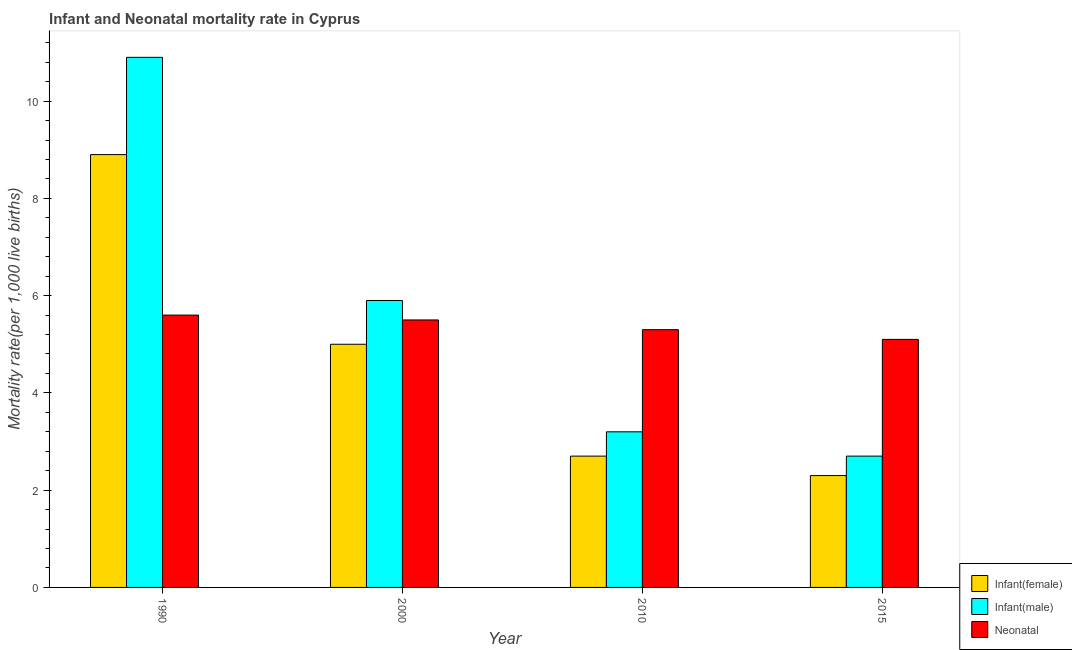How many different coloured bars are there?
Ensure brevity in your answer.  3. Are the number of bars per tick equal to the number of legend labels?
Offer a very short reply. Yes. How many bars are there on the 4th tick from the right?
Your answer should be very brief. 3. In how many cases, is the number of bars for a given year not equal to the number of legend labels?
Your answer should be compact. 0. What is the infant mortality rate(male) in 1990?
Ensure brevity in your answer.  10.9. Across all years, what is the maximum neonatal mortality rate?
Offer a very short reply. 5.6. In which year was the infant mortality rate(male) minimum?
Make the answer very short. 2015. What is the difference between the neonatal mortality rate in 2000 and that in 2010?
Give a very brief answer. 0.2. What is the average neonatal mortality rate per year?
Offer a very short reply. 5.38. In how many years, is the infant mortality rate(male) greater than 5.2?
Your answer should be very brief. 2. What is the ratio of the neonatal mortality rate in 2010 to that in 2015?
Give a very brief answer. 1.04. Is the difference between the infant mortality rate(male) in 1990 and 2010 greater than the difference between the neonatal mortality rate in 1990 and 2010?
Provide a short and direct response. No. What is the difference between the highest and the second highest neonatal mortality rate?
Give a very brief answer. 0.1. What is the difference between the highest and the lowest infant mortality rate(male)?
Provide a short and direct response. 8.2. Is the sum of the infant mortality rate(male) in 1990 and 2010 greater than the maximum infant mortality rate(female) across all years?
Make the answer very short. Yes. What does the 2nd bar from the left in 1990 represents?
Offer a terse response. Infant(male). What does the 3rd bar from the right in 2015 represents?
Keep it short and to the point. Infant(female). Is it the case that in every year, the sum of the infant mortality rate(female) and infant mortality rate(male) is greater than the neonatal mortality rate?
Your answer should be very brief. No. Are all the bars in the graph horizontal?
Your response must be concise. No. How many years are there in the graph?
Make the answer very short. 4. What is the difference between two consecutive major ticks on the Y-axis?
Give a very brief answer. 2. Are the values on the major ticks of Y-axis written in scientific E-notation?
Provide a succinct answer. No. What is the title of the graph?
Your answer should be compact. Infant and Neonatal mortality rate in Cyprus. What is the label or title of the Y-axis?
Ensure brevity in your answer.  Mortality rate(per 1,0 live births). What is the Mortality rate(per 1,000 live births) of Infant(female) in 1990?
Provide a short and direct response. 8.9. What is the Mortality rate(per 1,000 live births) in Infant(male) in 1990?
Offer a very short reply. 10.9. What is the Mortality rate(per 1,000 live births) in Neonatal  in 1990?
Provide a short and direct response. 5.6. What is the Mortality rate(per 1,000 live births) in Infant(female) in 2000?
Your response must be concise. 5. What is the Mortality rate(per 1,000 live births) of Neonatal  in 2000?
Your answer should be compact. 5.5. What is the Mortality rate(per 1,000 live births) of Neonatal  in 2010?
Provide a succinct answer. 5.3. What is the Mortality rate(per 1,000 live births) of Infant(female) in 2015?
Provide a succinct answer. 2.3. What is the Mortality rate(per 1,000 live births) of Neonatal  in 2015?
Give a very brief answer. 5.1. Across all years, what is the maximum Mortality rate(per 1,000 live births) in Infant(male)?
Offer a very short reply. 10.9. Across all years, what is the minimum Mortality rate(per 1,000 live births) in Neonatal ?
Provide a short and direct response. 5.1. What is the total Mortality rate(per 1,000 live births) in Infant(male) in the graph?
Your response must be concise. 22.7. What is the total Mortality rate(per 1,000 live births) of Neonatal  in the graph?
Your response must be concise. 21.5. What is the difference between the Mortality rate(per 1,000 live births) of Infant(male) in 1990 and that in 2000?
Keep it short and to the point. 5. What is the difference between the Mortality rate(per 1,000 live births) in Neonatal  in 1990 and that in 2000?
Your answer should be very brief. 0.1. What is the difference between the Mortality rate(per 1,000 live births) of Infant(female) in 2000 and that in 2010?
Offer a terse response. 2.3. What is the difference between the Mortality rate(per 1,000 live births) in Infant(male) in 2000 and that in 2010?
Offer a terse response. 2.7. What is the difference between the Mortality rate(per 1,000 live births) of Neonatal  in 2000 and that in 2010?
Offer a very short reply. 0.2. What is the difference between the Mortality rate(per 1,000 live births) of Infant(male) in 2000 and that in 2015?
Your response must be concise. 3.2. What is the difference between the Mortality rate(per 1,000 live births) in Neonatal  in 2010 and that in 2015?
Your answer should be compact. 0.2. What is the difference between the Mortality rate(per 1,000 live births) of Infant(female) in 1990 and the Mortality rate(per 1,000 live births) of Neonatal  in 2000?
Ensure brevity in your answer.  3.4. What is the difference between the Mortality rate(per 1,000 live births) in Infant(male) in 1990 and the Mortality rate(per 1,000 live births) in Neonatal  in 2000?
Your answer should be compact. 5.4. What is the difference between the Mortality rate(per 1,000 live births) of Infant(male) in 1990 and the Mortality rate(per 1,000 live births) of Neonatal  in 2010?
Offer a very short reply. 5.6. What is the difference between the Mortality rate(per 1,000 live births) in Infant(female) in 1990 and the Mortality rate(per 1,000 live births) in Neonatal  in 2015?
Your answer should be compact. 3.8. What is the difference between the Mortality rate(per 1,000 live births) in Infant(female) in 2000 and the Mortality rate(per 1,000 live births) in Infant(male) in 2010?
Your answer should be compact. 1.8. What is the difference between the Mortality rate(per 1,000 live births) of Infant(male) in 2010 and the Mortality rate(per 1,000 live births) of Neonatal  in 2015?
Give a very brief answer. -1.9. What is the average Mortality rate(per 1,000 live births) of Infant(female) per year?
Your answer should be compact. 4.72. What is the average Mortality rate(per 1,000 live births) of Infant(male) per year?
Provide a succinct answer. 5.67. What is the average Mortality rate(per 1,000 live births) in Neonatal  per year?
Your answer should be compact. 5.38. In the year 1990, what is the difference between the Mortality rate(per 1,000 live births) in Infant(female) and Mortality rate(per 1,000 live births) in Neonatal ?
Keep it short and to the point. 3.3. In the year 2000, what is the difference between the Mortality rate(per 1,000 live births) of Infant(female) and Mortality rate(per 1,000 live births) of Infant(male)?
Your answer should be compact. -0.9. In the year 2000, what is the difference between the Mortality rate(per 1,000 live births) of Infant(female) and Mortality rate(per 1,000 live births) of Neonatal ?
Offer a very short reply. -0.5. In the year 2010, what is the difference between the Mortality rate(per 1,000 live births) in Infant(female) and Mortality rate(per 1,000 live births) in Neonatal ?
Keep it short and to the point. -2.6. In the year 2010, what is the difference between the Mortality rate(per 1,000 live births) of Infant(male) and Mortality rate(per 1,000 live births) of Neonatal ?
Your answer should be very brief. -2.1. In the year 2015, what is the difference between the Mortality rate(per 1,000 live births) in Infant(female) and Mortality rate(per 1,000 live births) in Infant(male)?
Offer a terse response. -0.4. In the year 2015, what is the difference between the Mortality rate(per 1,000 live births) in Infant(female) and Mortality rate(per 1,000 live births) in Neonatal ?
Give a very brief answer. -2.8. In the year 2015, what is the difference between the Mortality rate(per 1,000 live births) in Infant(male) and Mortality rate(per 1,000 live births) in Neonatal ?
Provide a succinct answer. -2.4. What is the ratio of the Mortality rate(per 1,000 live births) of Infant(female) in 1990 to that in 2000?
Ensure brevity in your answer.  1.78. What is the ratio of the Mortality rate(per 1,000 live births) in Infant(male) in 1990 to that in 2000?
Ensure brevity in your answer.  1.85. What is the ratio of the Mortality rate(per 1,000 live births) in Neonatal  in 1990 to that in 2000?
Your response must be concise. 1.02. What is the ratio of the Mortality rate(per 1,000 live births) of Infant(female) in 1990 to that in 2010?
Keep it short and to the point. 3.3. What is the ratio of the Mortality rate(per 1,000 live births) in Infant(male) in 1990 to that in 2010?
Offer a very short reply. 3.41. What is the ratio of the Mortality rate(per 1,000 live births) of Neonatal  in 1990 to that in 2010?
Your answer should be very brief. 1.06. What is the ratio of the Mortality rate(per 1,000 live births) of Infant(female) in 1990 to that in 2015?
Your response must be concise. 3.87. What is the ratio of the Mortality rate(per 1,000 live births) of Infant(male) in 1990 to that in 2015?
Your answer should be very brief. 4.04. What is the ratio of the Mortality rate(per 1,000 live births) in Neonatal  in 1990 to that in 2015?
Provide a short and direct response. 1.1. What is the ratio of the Mortality rate(per 1,000 live births) in Infant(female) in 2000 to that in 2010?
Make the answer very short. 1.85. What is the ratio of the Mortality rate(per 1,000 live births) of Infant(male) in 2000 to that in 2010?
Ensure brevity in your answer.  1.84. What is the ratio of the Mortality rate(per 1,000 live births) of Neonatal  in 2000 to that in 2010?
Provide a succinct answer. 1.04. What is the ratio of the Mortality rate(per 1,000 live births) of Infant(female) in 2000 to that in 2015?
Your answer should be very brief. 2.17. What is the ratio of the Mortality rate(per 1,000 live births) in Infant(male) in 2000 to that in 2015?
Your answer should be very brief. 2.19. What is the ratio of the Mortality rate(per 1,000 live births) of Neonatal  in 2000 to that in 2015?
Offer a terse response. 1.08. What is the ratio of the Mortality rate(per 1,000 live births) of Infant(female) in 2010 to that in 2015?
Offer a very short reply. 1.17. What is the ratio of the Mortality rate(per 1,000 live births) of Infant(male) in 2010 to that in 2015?
Provide a short and direct response. 1.19. What is the ratio of the Mortality rate(per 1,000 live births) of Neonatal  in 2010 to that in 2015?
Give a very brief answer. 1.04. What is the difference between the highest and the second highest Mortality rate(per 1,000 live births) in Infant(male)?
Your answer should be very brief. 5. What is the difference between the highest and the lowest Mortality rate(per 1,000 live births) of Neonatal ?
Provide a short and direct response. 0.5. 